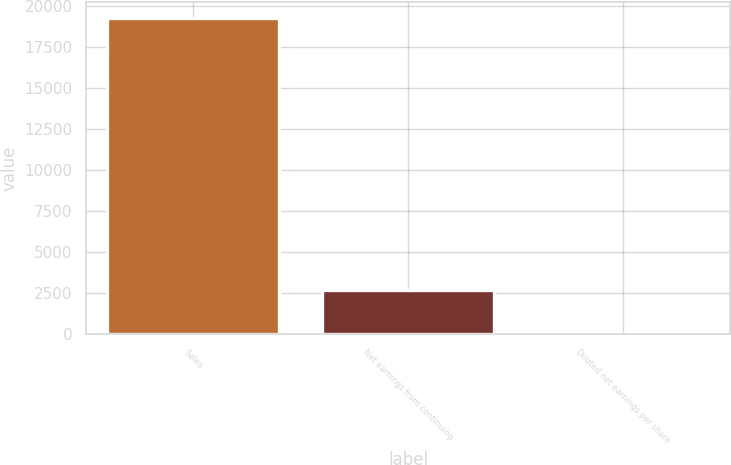<chart> <loc_0><loc_0><loc_500><loc_500><bar_chart><fcel>Sales<fcel>Net earnings from continuing<fcel>Diluted net earnings per share<nl><fcel>19263.1<fcel>2698.4<fcel>3.8<nl></chart> 